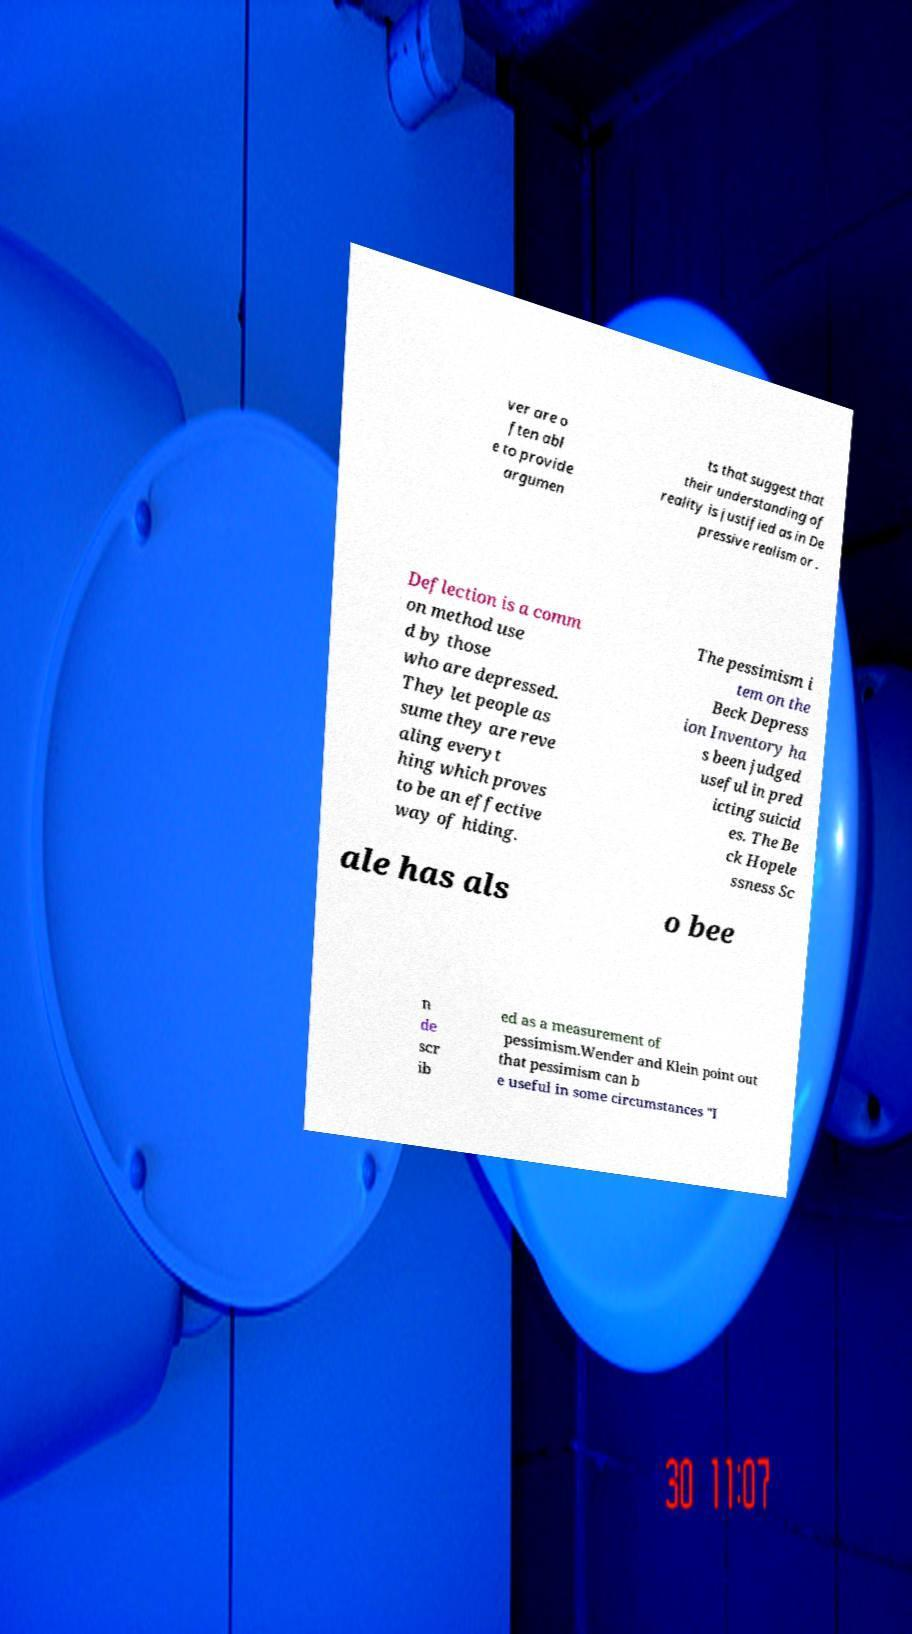Please identify and transcribe the text found in this image. ver are o ften abl e to provide argumen ts that suggest that their understanding of reality is justified as in De pressive realism or . Deflection is a comm on method use d by those who are depressed. They let people as sume they are reve aling everyt hing which proves to be an effective way of hiding. The pessimism i tem on the Beck Depress ion Inventory ha s been judged useful in pred icting suicid es. The Be ck Hopele ssness Sc ale has als o bee n de scr ib ed as a measurement of pessimism.Wender and Klein point out that pessimism can b e useful in some circumstances "I 